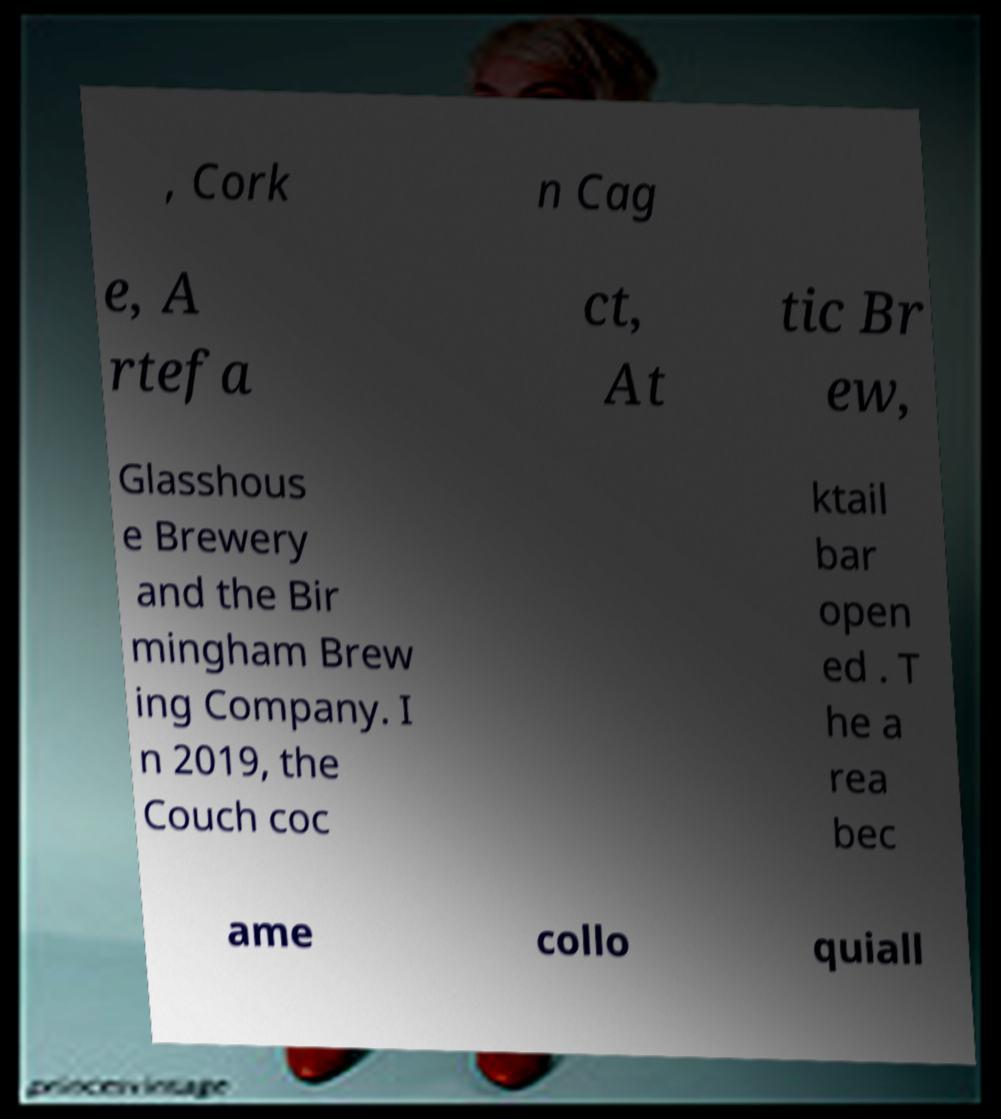Please identify and transcribe the text found in this image. , Cork n Cag e, A rtefa ct, At tic Br ew, Glasshous e Brewery and the Bir mingham Brew ing Company. I n 2019, the Couch coc ktail bar open ed . T he a rea bec ame collo quiall 